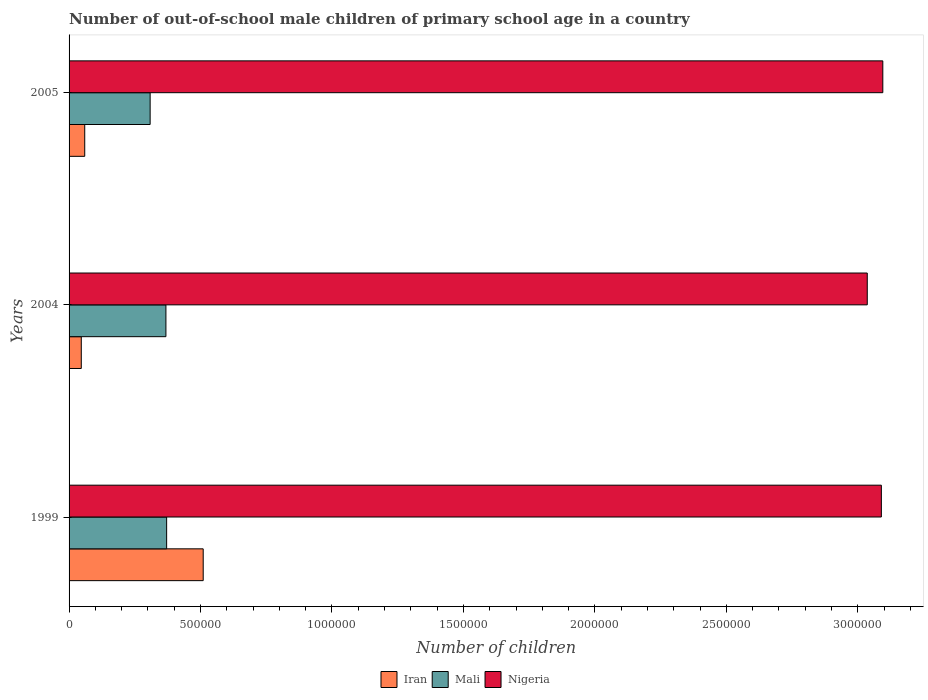Are the number of bars on each tick of the Y-axis equal?
Your response must be concise. Yes. How many bars are there on the 3rd tick from the top?
Offer a very short reply. 3. How many bars are there on the 2nd tick from the bottom?
Your answer should be very brief. 3. In how many cases, is the number of bars for a given year not equal to the number of legend labels?
Offer a terse response. 0. What is the number of out-of-school male children in Iran in 1999?
Offer a very short reply. 5.10e+05. Across all years, what is the maximum number of out-of-school male children in Iran?
Keep it short and to the point. 5.10e+05. Across all years, what is the minimum number of out-of-school male children in Iran?
Offer a terse response. 4.65e+04. In which year was the number of out-of-school male children in Mali maximum?
Ensure brevity in your answer.  1999. In which year was the number of out-of-school male children in Nigeria minimum?
Offer a very short reply. 2004. What is the total number of out-of-school male children in Iran in the graph?
Provide a short and direct response. 6.16e+05. What is the difference between the number of out-of-school male children in Nigeria in 2004 and that in 2005?
Ensure brevity in your answer.  -5.91e+04. What is the difference between the number of out-of-school male children in Iran in 2004 and the number of out-of-school male children in Mali in 1999?
Provide a short and direct response. -3.25e+05. What is the average number of out-of-school male children in Nigeria per year?
Ensure brevity in your answer.  3.07e+06. In the year 2005, what is the difference between the number of out-of-school male children in Iran and number of out-of-school male children in Nigeria?
Give a very brief answer. -3.04e+06. In how many years, is the number of out-of-school male children in Iran greater than 1900000 ?
Your answer should be compact. 0. What is the ratio of the number of out-of-school male children in Iran in 1999 to that in 2005?
Offer a terse response. 8.56. Is the number of out-of-school male children in Nigeria in 1999 less than that in 2005?
Your answer should be compact. Yes. What is the difference between the highest and the second highest number of out-of-school male children in Mali?
Make the answer very short. 2702. What is the difference between the highest and the lowest number of out-of-school male children in Mali?
Give a very brief answer. 6.27e+04. What does the 1st bar from the top in 2004 represents?
Your response must be concise. Nigeria. What does the 1st bar from the bottom in 2005 represents?
Provide a short and direct response. Iran. Is it the case that in every year, the sum of the number of out-of-school male children in Nigeria and number of out-of-school male children in Iran is greater than the number of out-of-school male children in Mali?
Your answer should be compact. Yes. How many bars are there?
Your answer should be compact. 9. How many years are there in the graph?
Offer a very short reply. 3. What is the difference between two consecutive major ticks on the X-axis?
Offer a very short reply. 5.00e+05. Does the graph contain any zero values?
Give a very brief answer. No. Where does the legend appear in the graph?
Offer a very short reply. Bottom center. How are the legend labels stacked?
Your response must be concise. Horizontal. What is the title of the graph?
Give a very brief answer. Number of out-of-school male children of primary school age in a country. What is the label or title of the X-axis?
Offer a terse response. Number of children. What is the Number of children of Iran in 1999?
Offer a terse response. 5.10e+05. What is the Number of children of Mali in 1999?
Your answer should be compact. 3.71e+05. What is the Number of children of Nigeria in 1999?
Keep it short and to the point. 3.09e+06. What is the Number of children of Iran in 2004?
Your response must be concise. 4.65e+04. What is the Number of children of Mali in 2004?
Offer a very short reply. 3.68e+05. What is the Number of children in Nigeria in 2004?
Provide a succinct answer. 3.04e+06. What is the Number of children of Iran in 2005?
Make the answer very short. 5.96e+04. What is the Number of children of Mali in 2005?
Your answer should be compact. 3.08e+05. What is the Number of children of Nigeria in 2005?
Your answer should be compact. 3.10e+06. Across all years, what is the maximum Number of children in Iran?
Make the answer very short. 5.10e+05. Across all years, what is the maximum Number of children of Mali?
Provide a short and direct response. 3.71e+05. Across all years, what is the maximum Number of children in Nigeria?
Keep it short and to the point. 3.10e+06. Across all years, what is the minimum Number of children of Iran?
Give a very brief answer. 4.65e+04. Across all years, what is the minimum Number of children in Mali?
Provide a succinct answer. 3.08e+05. Across all years, what is the minimum Number of children of Nigeria?
Give a very brief answer. 3.04e+06. What is the total Number of children of Iran in the graph?
Keep it short and to the point. 6.16e+05. What is the total Number of children in Mali in the graph?
Make the answer very short. 1.05e+06. What is the total Number of children of Nigeria in the graph?
Offer a very short reply. 9.22e+06. What is the difference between the Number of children in Iran in 1999 and that in 2004?
Make the answer very short. 4.64e+05. What is the difference between the Number of children in Mali in 1999 and that in 2004?
Keep it short and to the point. 2702. What is the difference between the Number of children of Nigeria in 1999 and that in 2004?
Your answer should be very brief. 5.36e+04. What is the difference between the Number of children of Iran in 1999 and that in 2005?
Give a very brief answer. 4.51e+05. What is the difference between the Number of children of Mali in 1999 and that in 2005?
Make the answer very short. 6.27e+04. What is the difference between the Number of children in Nigeria in 1999 and that in 2005?
Provide a succinct answer. -5498. What is the difference between the Number of children in Iran in 2004 and that in 2005?
Ensure brevity in your answer.  -1.31e+04. What is the difference between the Number of children of Mali in 2004 and that in 2005?
Make the answer very short. 6.00e+04. What is the difference between the Number of children in Nigeria in 2004 and that in 2005?
Keep it short and to the point. -5.91e+04. What is the difference between the Number of children of Iran in 1999 and the Number of children of Mali in 2004?
Give a very brief answer. 1.42e+05. What is the difference between the Number of children in Iran in 1999 and the Number of children in Nigeria in 2004?
Make the answer very short. -2.53e+06. What is the difference between the Number of children in Mali in 1999 and the Number of children in Nigeria in 2004?
Give a very brief answer. -2.66e+06. What is the difference between the Number of children in Iran in 1999 and the Number of children in Mali in 2005?
Make the answer very short. 2.02e+05. What is the difference between the Number of children in Iran in 1999 and the Number of children in Nigeria in 2005?
Provide a short and direct response. -2.58e+06. What is the difference between the Number of children of Mali in 1999 and the Number of children of Nigeria in 2005?
Your response must be concise. -2.72e+06. What is the difference between the Number of children in Iran in 2004 and the Number of children in Mali in 2005?
Offer a terse response. -2.62e+05. What is the difference between the Number of children of Iran in 2004 and the Number of children of Nigeria in 2005?
Ensure brevity in your answer.  -3.05e+06. What is the difference between the Number of children in Mali in 2004 and the Number of children in Nigeria in 2005?
Keep it short and to the point. -2.73e+06. What is the average Number of children of Iran per year?
Provide a succinct answer. 2.05e+05. What is the average Number of children of Mali per year?
Provide a short and direct response. 3.49e+05. What is the average Number of children in Nigeria per year?
Provide a succinct answer. 3.07e+06. In the year 1999, what is the difference between the Number of children in Iran and Number of children in Mali?
Give a very brief answer. 1.39e+05. In the year 1999, what is the difference between the Number of children of Iran and Number of children of Nigeria?
Give a very brief answer. -2.58e+06. In the year 1999, what is the difference between the Number of children of Mali and Number of children of Nigeria?
Ensure brevity in your answer.  -2.72e+06. In the year 2004, what is the difference between the Number of children of Iran and Number of children of Mali?
Keep it short and to the point. -3.22e+05. In the year 2004, what is the difference between the Number of children in Iran and Number of children in Nigeria?
Make the answer very short. -2.99e+06. In the year 2004, what is the difference between the Number of children of Mali and Number of children of Nigeria?
Offer a terse response. -2.67e+06. In the year 2005, what is the difference between the Number of children of Iran and Number of children of Mali?
Provide a short and direct response. -2.49e+05. In the year 2005, what is the difference between the Number of children in Iran and Number of children in Nigeria?
Keep it short and to the point. -3.04e+06. In the year 2005, what is the difference between the Number of children of Mali and Number of children of Nigeria?
Provide a succinct answer. -2.79e+06. What is the ratio of the Number of children of Iran in 1999 to that in 2004?
Give a very brief answer. 10.98. What is the ratio of the Number of children in Mali in 1999 to that in 2004?
Make the answer very short. 1.01. What is the ratio of the Number of children of Nigeria in 1999 to that in 2004?
Your answer should be compact. 1.02. What is the ratio of the Number of children of Iran in 1999 to that in 2005?
Your response must be concise. 8.56. What is the ratio of the Number of children of Mali in 1999 to that in 2005?
Provide a succinct answer. 1.2. What is the ratio of the Number of children in Nigeria in 1999 to that in 2005?
Offer a very short reply. 1. What is the ratio of the Number of children in Iran in 2004 to that in 2005?
Make the answer very short. 0.78. What is the ratio of the Number of children in Mali in 2004 to that in 2005?
Ensure brevity in your answer.  1.19. What is the ratio of the Number of children of Nigeria in 2004 to that in 2005?
Your answer should be compact. 0.98. What is the difference between the highest and the second highest Number of children in Iran?
Provide a succinct answer. 4.51e+05. What is the difference between the highest and the second highest Number of children of Mali?
Your answer should be compact. 2702. What is the difference between the highest and the second highest Number of children of Nigeria?
Make the answer very short. 5498. What is the difference between the highest and the lowest Number of children of Iran?
Your answer should be very brief. 4.64e+05. What is the difference between the highest and the lowest Number of children in Mali?
Offer a terse response. 6.27e+04. What is the difference between the highest and the lowest Number of children of Nigeria?
Your answer should be compact. 5.91e+04. 